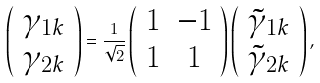<formula> <loc_0><loc_0><loc_500><loc_500>\left ( \begin{array} { c } \gamma _ { 1 k } \\ \gamma _ { 2 k } \\ \end{array} \right ) = \frac { 1 } { \sqrt { 2 } } \left ( \begin{array} { c c } 1 & - 1 \\ 1 & 1 \\ \end{array} \right ) \left ( \begin{array} { c } \tilde { \gamma } _ { 1 k } \\ \tilde { \gamma } _ { 2 k } \\ \end{array} \right ) ,</formula> 